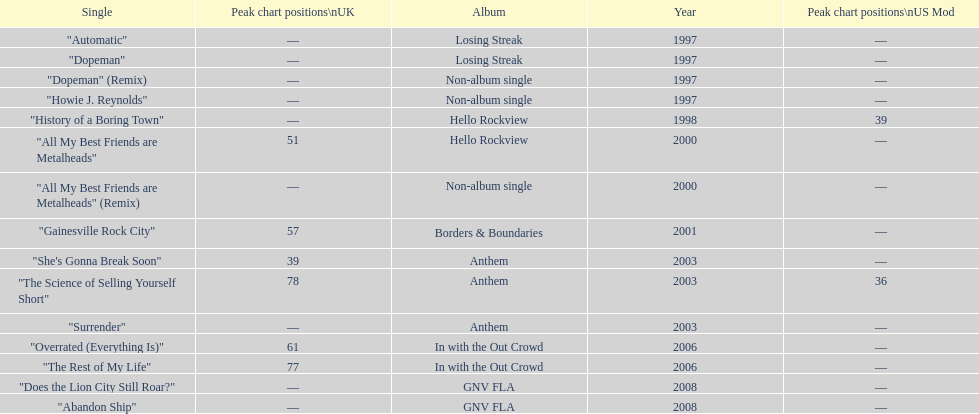What was the next single after "overrated (everything is)"? "The Rest of My Life". 